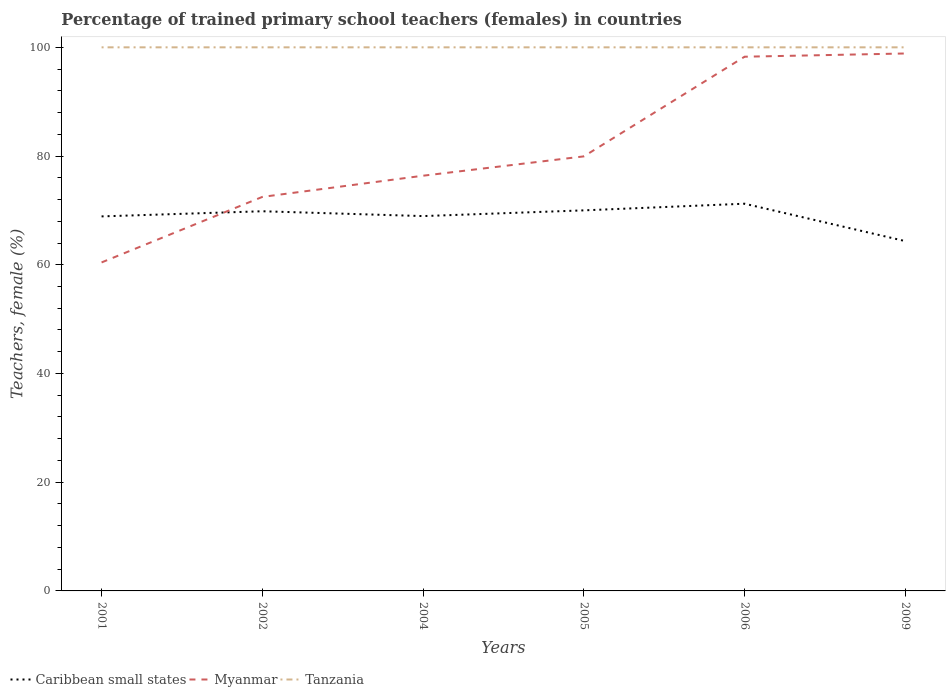How many different coloured lines are there?
Your answer should be compact. 3. Does the line corresponding to Myanmar intersect with the line corresponding to Caribbean small states?
Give a very brief answer. Yes. Is the number of lines equal to the number of legend labels?
Your answer should be very brief. Yes. Across all years, what is the maximum percentage of trained primary school teachers (females) in Tanzania?
Provide a short and direct response. 100. What is the total percentage of trained primary school teachers (females) in Tanzania in the graph?
Your answer should be very brief. 0. What is the difference between the highest and the second highest percentage of trained primary school teachers (females) in Caribbean small states?
Give a very brief answer. 6.88. How many lines are there?
Your response must be concise. 3. How many years are there in the graph?
Your answer should be very brief. 6. Are the values on the major ticks of Y-axis written in scientific E-notation?
Provide a short and direct response. No. Does the graph contain grids?
Your answer should be very brief. No. How many legend labels are there?
Make the answer very short. 3. How are the legend labels stacked?
Make the answer very short. Horizontal. What is the title of the graph?
Your response must be concise. Percentage of trained primary school teachers (females) in countries. What is the label or title of the X-axis?
Give a very brief answer. Years. What is the label or title of the Y-axis?
Give a very brief answer. Teachers, female (%). What is the Teachers, female (%) in Caribbean small states in 2001?
Your response must be concise. 68.9. What is the Teachers, female (%) of Myanmar in 2001?
Give a very brief answer. 60.43. What is the Teachers, female (%) in Caribbean small states in 2002?
Give a very brief answer. 69.85. What is the Teachers, female (%) in Myanmar in 2002?
Your answer should be very brief. 72.48. What is the Teachers, female (%) of Caribbean small states in 2004?
Offer a terse response. 68.96. What is the Teachers, female (%) in Myanmar in 2004?
Your answer should be very brief. 76.38. What is the Teachers, female (%) in Tanzania in 2004?
Offer a very short reply. 100. What is the Teachers, female (%) in Caribbean small states in 2005?
Offer a terse response. 70.01. What is the Teachers, female (%) of Myanmar in 2005?
Make the answer very short. 79.94. What is the Teachers, female (%) of Caribbean small states in 2006?
Offer a terse response. 71.23. What is the Teachers, female (%) of Myanmar in 2006?
Provide a short and direct response. 98.27. What is the Teachers, female (%) of Caribbean small states in 2009?
Ensure brevity in your answer.  64.35. What is the Teachers, female (%) in Myanmar in 2009?
Provide a succinct answer. 98.87. What is the Teachers, female (%) of Tanzania in 2009?
Make the answer very short. 100. Across all years, what is the maximum Teachers, female (%) in Caribbean small states?
Offer a very short reply. 71.23. Across all years, what is the maximum Teachers, female (%) in Myanmar?
Your answer should be compact. 98.87. Across all years, what is the minimum Teachers, female (%) in Caribbean small states?
Provide a succinct answer. 64.35. Across all years, what is the minimum Teachers, female (%) of Myanmar?
Keep it short and to the point. 60.43. What is the total Teachers, female (%) in Caribbean small states in the graph?
Your answer should be very brief. 413.29. What is the total Teachers, female (%) in Myanmar in the graph?
Offer a terse response. 486.38. What is the total Teachers, female (%) in Tanzania in the graph?
Provide a short and direct response. 600. What is the difference between the Teachers, female (%) in Caribbean small states in 2001 and that in 2002?
Offer a very short reply. -0.95. What is the difference between the Teachers, female (%) in Myanmar in 2001 and that in 2002?
Your answer should be compact. -12.05. What is the difference between the Teachers, female (%) of Tanzania in 2001 and that in 2002?
Make the answer very short. 0. What is the difference between the Teachers, female (%) of Caribbean small states in 2001 and that in 2004?
Give a very brief answer. -0.06. What is the difference between the Teachers, female (%) in Myanmar in 2001 and that in 2004?
Provide a short and direct response. -15.95. What is the difference between the Teachers, female (%) in Caribbean small states in 2001 and that in 2005?
Provide a short and direct response. -1.11. What is the difference between the Teachers, female (%) of Myanmar in 2001 and that in 2005?
Your answer should be compact. -19.51. What is the difference between the Teachers, female (%) in Tanzania in 2001 and that in 2005?
Offer a terse response. 0. What is the difference between the Teachers, female (%) in Caribbean small states in 2001 and that in 2006?
Your response must be concise. -2.33. What is the difference between the Teachers, female (%) of Myanmar in 2001 and that in 2006?
Your response must be concise. -37.84. What is the difference between the Teachers, female (%) of Tanzania in 2001 and that in 2006?
Your answer should be compact. 0. What is the difference between the Teachers, female (%) in Caribbean small states in 2001 and that in 2009?
Ensure brevity in your answer.  4.55. What is the difference between the Teachers, female (%) of Myanmar in 2001 and that in 2009?
Your response must be concise. -38.44. What is the difference between the Teachers, female (%) of Caribbean small states in 2002 and that in 2004?
Your response must be concise. 0.89. What is the difference between the Teachers, female (%) in Myanmar in 2002 and that in 2004?
Offer a terse response. -3.9. What is the difference between the Teachers, female (%) of Caribbean small states in 2002 and that in 2005?
Provide a short and direct response. -0.16. What is the difference between the Teachers, female (%) in Myanmar in 2002 and that in 2005?
Offer a very short reply. -7.46. What is the difference between the Teachers, female (%) in Caribbean small states in 2002 and that in 2006?
Ensure brevity in your answer.  -1.39. What is the difference between the Teachers, female (%) in Myanmar in 2002 and that in 2006?
Offer a very short reply. -25.79. What is the difference between the Teachers, female (%) in Caribbean small states in 2002 and that in 2009?
Keep it short and to the point. 5.49. What is the difference between the Teachers, female (%) in Myanmar in 2002 and that in 2009?
Provide a short and direct response. -26.38. What is the difference between the Teachers, female (%) of Caribbean small states in 2004 and that in 2005?
Give a very brief answer. -1.05. What is the difference between the Teachers, female (%) in Myanmar in 2004 and that in 2005?
Make the answer very short. -3.56. What is the difference between the Teachers, female (%) in Caribbean small states in 2004 and that in 2006?
Give a very brief answer. -2.28. What is the difference between the Teachers, female (%) of Myanmar in 2004 and that in 2006?
Ensure brevity in your answer.  -21.89. What is the difference between the Teachers, female (%) in Caribbean small states in 2004 and that in 2009?
Offer a very short reply. 4.6. What is the difference between the Teachers, female (%) of Myanmar in 2004 and that in 2009?
Provide a succinct answer. -22.49. What is the difference between the Teachers, female (%) in Tanzania in 2004 and that in 2009?
Keep it short and to the point. 0. What is the difference between the Teachers, female (%) in Caribbean small states in 2005 and that in 2006?
Your response must be concise. -1.22. What is the difference between the Teachers, female (%) of Myanmar in 2005 and that in 2006?
Provide a short and direct response. -18.33. What is the difference between the Teachers, female (%) in Caribbean small states in 2005 and that in 2009?
Your response must be concise. 5.66. What is the difference between the Teachers, female (%) in Myanmar in 2005 and that in 2009?
Give a very brief answer. -18.93. What is the difference between the Teachers, female (%) of Caribbean small states in 2006 and that in 2009?
Your response must be concise. 6.88. What is the difference between the Teachers, female (%) of Myanmar in 2006 and that in 2009?
Provide a succinct answer. -0.6. What is the difference between the Teachers, female (%) of Tanzania in 2006 and that in 2009?
Your answer should be very brief. 0. What is the difference between the Teachers, female (%) in Caribbean small states in 2001 and the Teachers, female (%) in Myanmar in 2002?
Offer a terse response. -3.59. What is the difference between the Teachers, female (%) of Caribbean small states in 2001 and the Teachers, female (%) of Tanzania in 2002?
Ensure brevity in your answer.  -31.1. What is the difference between the Teachers, female (%) in Myanmar in 2001 and the Teachers, female (%) in Tanzania in 2002?
Offer a very short reply. -39.57. What is the difference between the Teachers, female (%) of Caribbean small states in 2001 and the Teachers, female (%) of Myanmar in 2004?
Your answer should be compact. -7.48. What is the difference between the Teachers, female (%) of Caribbean small states in 2001 and the Teachers, female (%) of Tanzania in 2004?
Ensure brevity in your answer.  -31.1. What is the difference between the Teachers, female (%) in Myanmar in 2001 and the Teachers, female (%) in Tanzania in 2004?
Offer a very short reply. -39.57. What is the difference between the Teachers, female (%) in Caribbean small states in 2001 and the Teachers, female (%) in Myanmar in 2005?
Your response must be concise. -11.04. What is the difference between the Teachers, female (%) of Caribbean small states in 2001 and the Teachers, female (%) of Tanzania in 2005?
Your response must be concise. -31.1. What is the difference between the Teachers, female (%) in Myanmar in 2001 and the Teachers, female (%) in Tanzania in 2005?
Keep it short and to the point. -39.57. What is the difference between the Teachers, female (%) of Caribbean small states in 2001 and the Teachers, female (%) of Myanmar in 2006?
Ensure brevity in your answer.  -29.37. What is the difference between the Teachers, female (%) in Caribbean small states in 2001 and the Teachers, female (%) in Tanzania in 2006?
Offer a terse response. -31.1. What is the difference between the Teachers, female (%) in Myanmar in 2001 and the Teachers, female (%) in Tanzania in 2006?
Offer a very short reply. -39.57. What is the difference between the Teachers, female (%) in Caribbean small states in 2001 and the Teachers, female (%) in Myanmar in 2009?
Your answer should be very brief. -29.97. What is the difference between the Teachers, female (%) in Caribbean small states in 2001 and the Teachers, female (%) in Tanzania in 2009?
Offer a very short reply. -31.1. What is the difference between the Teachers, female (%) of Myanmar in 2001 and the Teachers, female (%) of Tanzania in 2009?
Make the answer very short. -39.57. What is the difference between the Teachers, female (%) in Caribbean small states in 2002 and the Teachers, female (%) in Myanmar in 2004?
Ensure brevity in your answer.  -6.54. What is the difference between the Teachers, female (%) in Caribbean small states in 2002 and the Teachers, female (%) in Tanzania in 2004?
Your answer should be compact. -30.16. What is the difference between the Teachers, female (%) in Myanmar in 2002 and the Teachers, female (%) in Tanzania in 2004?
Provide a short and direct response. -27.52. What is the difference between the Teachers, female (%) in Caribbean small states in 2002 and the Teachers, female (%) in Myanmar in 2005?
Your answer should be very brief. -10.09. What is the difference between the Teachers, female (%) in Caribbean small states in 2002 and the Teachers, female (%) in Tanzania in 2005?
Your answer should be compact. -30.16. What is the difference between the Teachers, female (%) of Myanmar in 2002 and the Teachers, female (%) of Tanzania in 2005?
Offer a very short reply. -27.52. What is the difference between the Teachers, female (%) in Caribbean small states in 2002 and the Teachers, female (%) in Myanmar in 2006?
Make the answer very short. -28.43. What is the difference between the Teachers, female (%) of Caribbean small states in 2002 and the Teachers, female (%) of Tanzania in 2006?
Offer a very short reply. -30.16. What is the difference between the Teachers, female (%) of Myanmar in 2002 and the Teachers, female (%) of Tanzania in 2006?
Keep it short and to the point. -27.52. What is the difference between the Teachers, female (%) in Caribbean small states in 2002 and the Teachers, female (%) in Myanmar in 2009?
Ensure brevity in your answer.  -29.02. What is the difference between the Teachers, female (%) in Caribbean small states in 2002 and the Teachers, female (%) in Tanzania in 2009?
Ensure brevity in your answer.  -30.16. What is the difference between the Teachers, female (%) of Myanmar in 2002 and the Teachers, female (%) of Tanzania in 2009?
Your response must be concise. -27.52. What is the difference between the Teachers, female (%) of Caribbean small states in 2004 and the Teachers, female (%) of Myanmar in 2005?
Offer a very short reply. -10.98. What is the difference between the Teachers, female (%) of Caribbean small states in 2004 and the Teachers, female (%) of Tanzania in 2005?
Provide a short and direct response. -31.04. What is the difference between the Teachers, female (%) of Myanmar in 2004 and the Teachers, female (%) of Tanzania in 2005?
Offer a terse response. -23.62. What is the difference between the Teachers, female (%) of Caribbean small states in 2004 and the Teachers, female (%) of Myanmar in 2006?
Give a very brief answer. -29.32. What is the difference between the Teachers, female (%) of Caribbean small states in 2004 and the Teachers, female (%) of Tanzania in 2006?
Make the answer very short. -31.04. What is the difference between the Teachers, female (%) in Myanmar in 2004 and the Teachers, female (%) in Tanzania in 2006?
Ensure brevity in your answer.  -23.62. What is the difference between the Teachers, female (%) in Caribbean small states in 2004 and the Teachers, female (%) in Myanmar in 2009?
Your answer should be very brief. -29.91. What is the difference between the Teachers, female (%) of Caribbean small states in 2004 and the Teachers, female (%) of Tanzania in 2009?
Provide a short and direct response. -31.04. What is the difference between the Teachers, female (%) in Myanmar in 2004 and the Teachers, female (%) in Tanzania in 2009?
Ensure brevity in your answer.  -23.62. What is the difference between the Teachers, female (%) in Caribbean small states in 2005 and the Teachers, female (%) in Myanmar in 2006?
Your answer should be compact. -28.26. What is the difference between the Teachers, female (%) of Caribbean small states in 2005 and the Teachers, female (%) of Tanzania in 2006?
Provide a succinct answer. -29.99. What is the difference between the Teachers, female (%) of Myanmar in 2005 and the Teachers, female (%) of Tanzania in 2006?
Offer a terse response. -20.06. What is the difference between the Teachers, female (%) in Caribbean small states in 2005 and the Teachers, female (%) in Myanmar in 2009?
Offer a terse response. -28.86. What is the difference between the Teachers, female (%) in Caribbean small states in 2005 and the Teachers, female (%) in Tanzania in 2009?
Your answer should be very brief. -29.99. What is the difference between the Teachers, female (%) of Myanmar in 2005 and the Teachers, female (%) of Tanzania in 2009?
Provide a succinct answer. -20.06. What is the difference between the Teachers, female (%) of Caribbean small states in 2006 and the Teachers, female (%) of Myanmar in 2009?
Your answer should be very brief. -27.64. What is the difference between the Teachers, female (%) of Caribbean small states in 2006 and the Teachers, female (%) of Tanzania in 2009?
Keep it short and to the point. -28.77. What is the difference between the Teachers, female (%) in Myanmar in 2006 and the Teachers, female (%) in Tanzania in 2009?
Your response must be concise. -1.73. What is the average Teachers, female (%) in Caribbean small states per year?
Make the answer very short. 68.88. What is the average Teachers, female (%) in Myanmar per year?
Give a very brief answer. 81.06. What is the average Teachers, female (%) in Tanzania per year?
Make the answer very short. 100. In the year 2001, what is the difference between the Teachers, female (%) in Caribbean small states and Teachers, female (%) in Myanmar?
Provide a short and direct response. 8.47. In the year 2001, what is the difference between the Teachers, female (%) of Caribbean small states and Teachers, female (%) of Tanzania?
Your answer should be compact. -31.1. In the year 2001, what is the difference between the Teachers, female (%) of Myanmar and Teachers, female (%) of Tanzania?
Provide a succinct answer. -39.57. In the year 2002, what is the difference between the Teachers, female (%) of Caribbean small states and Teachers, female (%) of Myanmar?
Provide a succinct answer. -2.64. In the year 2002, what is the difference between the Teachers, female (%) of Caribbean small states and Teachers, female (%) of Tanzania?
Your response must be concise. -30.16. In the year 2002, what is the difference between the Teachers, female (%) in Myanmar and Teachers, female (%) in Tanzania?
Ensure brevity in your answer.  -27.52. In the year 2004, what is the difference between the Teachers, female (%) of Caribbean small states and Teachers, female (%) of Myanmar?
Provide a short and direct response. -7.43. In the year 2004, what is the difference between the Teachers, female (%) in Caribbean small states and Teachers, female (%) in Tanzania?
Give a very brief answer. -31.04. In the year 2004, what is the difference between the Teachers, female (%) of Myanmar and Teachers, female (%) of Tanzania?
Ensure brevity in your answer.  -23.62. In the year 2005, what is the difference between the Teachers, female (%) in Caribbean small states and Teachers, female (%) in Myanmar?
Make the answer very short. -9.93. In the year 2005, what is the difference between the Teachers, female (%) in Caribbean small states and Teachers, female (%) in Tanzania?
Offer a very short reply. -29.99. In the year 2005, what is the difference between the Teachers, female (%) in Myanmar and Teachers, female (%) in Tanzania?
Give a very brief answer. -20.06. In the year 2006, what is the difference between the Teachers, female (%) of Caribbean small states and Teachers, female (%) of Myanmar?
Ensure brevity in your answer.  -27.04. In the year 2006, what is the difference between the Teachers, female (%) in Caribbean small states and Teachers, female (%) in Tanzania?
Your answer should be very brief. -28.77. In the year 2006, what is the difference between the Teachers, female (%) of Myanmar and Teachers, female (%) of Tanzania?
Your response must be concise. -1.73. In the year 2009, what is the difference between the Teachers, female (%) in Caribbean small states and Teachers, female (%) in Myanmar?
Offer a terse response. -34.52. In the year 2009, what is the difference between the Teachers, female (%) of Caribbean small states and Teachers, female (%) of Tanzania?
Provide a succinct answer. -35.65. In the year 2009, what is the difference between the Teachers, female (%) in Myanmar and Teachers, female (%) in Tanzania?
Offer a terse response. -1.13. What is the ratio of the Teachers, female (%) of Caribbean small states in 2001 to that in 2002?
Your answer should be compact. 0.99. What is the ratio of the Teachers, female (%) in Myanmar in 2001 to that in 2002?
Offer a very short reply. 0.83. What is the ratio of the Teachers, female (%) of Tanzania in 2001 to that in 2002?
Your answer should be compact. 1. What is the ratio of the Teachers, female (%) of Caribbean small states in 2001 to that in 2004?
Give a very brief answer. 1. What is the ratio of the Teachers, female (%) of Myanmar in 2001 to that in 2004?
Provide a short and direct response. 0.79. What is the ratio of the Teachers, female (%) of Tanzania in 2001 to that in 2004?
Offer a very short reply. 1. What is the ratio of the Teachers, female (%) in Caribbean small states in 2001 to that in 2005?
Give a very brief answer. 0.98. What is the ratio of the Teachers, female (%) of Myanmar in 2001 to that in 2005?
Your answer should be compact. 0.76. What is the ratio of the Teachers, female (%) in Caribbean small states in 2001 to that in 2006?
Your answer should be very brief. 0.97. What is the ratio of the Teachers, female (%) of Myanmar in 2001 to that in 2006?
Give a very brief answer. 0.61. What is the ratio of the Teachers, female (%) in Caribbean small states in 2001 to that in 2009?
Offer a very short reply. 1.07. What is the ratio of the Teachers, female (%) of Myanmar in 2001 to that in 2009?
Offer a terse response. 0.61. What is the ratio of the Teachers, female (%) of Tanzania in 2001 to that in 2009?
Offer a terse response. 1. What is the ratio of the Teachers, female (%) of Caribbean small states in 2002 to that in 2004?
Give a very brief answer. 1.01. What is the ratio of the Teachers, female (%) of Myanmar in 2002 to that in 2004?
Provide a short and direct response. 0.95. What is the ratio of the Teachers, female (%) of Caribbean small states in 2002 to that in 2005?
Provide a short and direct response. 1. What is the ratio of the Teachers, female (%) of Myanmar in 2002 to that in 2005?
Offer a terse response. 0.91. What is the ratio of the Teachers, female (%) of Caribbean small states in 2002 to that in 2006?
Provide a short and direct response. 0.98. What is the ratio of the Teachers, female (%) in Myanmar in 2002 to that in 2006?
Offer a very short reply. 0.74. What is the ratio of the Teachers, female (%) in Tanzania in 2002 to that in 2006?
Ensure brevity in your answer.  1. What is the ratio of the Teachers, female (%) in Caribbean small states in 2002 to that in 2009?
Provide a succinct answer. 1.09. What is the ratio of the Teachers, female (%) of Myanmar in 2002 to that in 2009?
Your answer should be compact. 0.73. What is the ratio of the Teachers, female (%) of Tanzania in 2002 to that in 2009?
Ensure brevity in your answer.  1. What is the ratio of the Teachers, female (%) in Caribbean small states in 2004 to that in 2005?
Provide a short and direct response. 0.98. What is the ratio of the Teachers, female (%) in Myanmar in 2004 to that in 2005?
Offer a terse response. 0.96. What is the ratio of the Teachers, female (%) of Tanzania in 2004 to that in 2005?
Provide a short and direct response. 1. What is the ratio of the Teachers, female (%) in Myanmar in 2004 to that in 2006?
Give a very brief answer. 0.78. What is the ratio of the Teachers, female (%) in Tanzania in 2004 to that in 2006?
Give a very brief answer. 1. What is the ratio of the Teachers, female (%) of Caribbean small states in 2004 to that in 2009?
Provide a short and direct response. 1.07. What is the ratio of the Teachers, female (%) of Myanmar in 2004 to that in 2009?
Your answer should be very brief. 0.77. What is the ratio of the Teachers, female (%) of Caribbean small states in 2005 to that in 2006?
Make the answer very short. 0.98. What is the ratio of the Teachers, female (%) in Myanmar in 2005 to that in 2006?
Your response must be concise. 0.81. What is the ratio of the Teachers, female (%) of Tanzania in 2005 to that in 2006?
Give a very brief answer. 1. What is the ratio of the Teachers, female (%) in Caribbean small states in 2005 to that in 2009?
Ensure brevity in your answer.  1.09. What is the ratio of the Teachers, female (%) in Myanmar in 2005 to that in 2009?
Keep it short and to the point. 0.81. What is the ratio of the Teachers, female (%) of Tanzania in 2005 to that in 2009?
Your answer should be compact. 1. What is the ratio of the Teachers, female (%) of Caribbean small states in 2006 to that in 2009?
Keep it short and to the point. 1.11. What is the ratio of the Teachers, female (%) of Myanmar in 2006 to that in 2009?
Your answer should be compact. 0.99. What is the ratio of the Teachers, female (%) in Tanzania in 2006 to that in 2009?
Offer a very short reply. 1. What is the difference between the highest and the second highest Teachers, female (%) of Caribbean small states?
Your response must be concise. 1.22. What is the difference between the highest and the second highest Teachers, female (%) in Myanmar?
Make the answer very short. 0.6. What is the difference between the highest and the second highest Teachers, female (%) in Tanzania?
Offer a very short reply. 0. What is the difference between the highest and the lowest Teachers, female (%) of Caribbean small states?
Provide a short and direct response. 6.88. What is the difference between the highest and the lowest Teachers, female (%) in Myanmar?
Offer a very short reply. 38.44. 